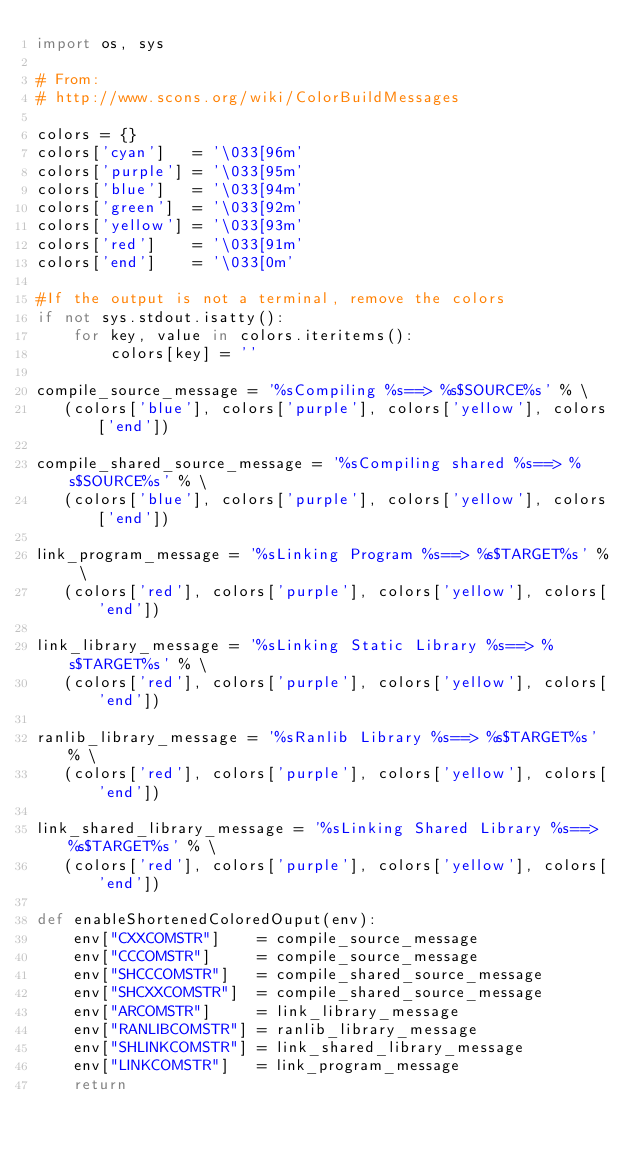Convert code to text. <code><loc_0><loc_0><loc_500><loc_500><_Python_>import os, sys

# From:
# http://www.scons.org/wiki/ColorBuildMessages

colors = {}
colors['cyan']   = '\033[96m'
colors['purple'] = '\033[95m'
colors['blue']   = '\033[94m'
colors['green']  = '\033[92m'
colors['yellow'] = '\033[93m'
colors['red']    = '\033[91m'
colors['end']    = '\033[0m'

#If the output is not a terminal, remove the colors
if not sys.stdout.isatty():
    for key, value in colors.iteritems():
        colors[key] = ''

compile_source_message = '%sCompiling %s==> %s$SOURCE%s' % \
   (colors['blue'], colors['purple'], colors['yellow'], colors['end'])

compile_shared_source_message = '%sCompiling shared %s==> %s$SOURCE%s' % \
   (colors['blue'], colors['purple'], colors['yellow'], colors['end'])

link_program_message = '%sLinking Program %s==> %s$TARGET%s' % \
   (colors['red'], colors['purple'], colors['yellow'], colors['end'])

link_library_message = '%sLinking Static Library %s==> %s$TARGET%s' % \
   (colors['red'], colors['purple'], colors['yellow'], colors['end'])

ranlib_library_message = '%sRanlib Library %s==> %s$TARGET%s' % \
   (colors['red'], colors['purple'], colors['yellow'], colors['end'])

link_shared_library_message = '%sLinking Shared Library %s==> %s$TARGET%s' % \
   (colors['red'], colors['purple'], colors['yellow'], colors['end'])

def enableShortenedColoredOuput(env):
    env["CXXCOMSTR"]    = compile_source_message
    env["CCCOMSTR"]     = compile_source_message
    env["SHCCCOMSTR"]   = compile_shared_source_message
    env["SHCXXCOMSTR"]  = compile_shared_source_message
    env["ARCOMSTR"]     = link_library_message
    env["RANLIBCOMSTR"] = ranlib_library_message
    env["SHLINKCOMSTR"] = link_shared_library_message
    env["LINKCOMSTR"]   = link_program_message
    return

</code> 